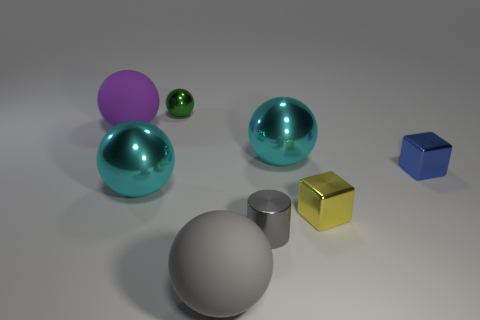Add 1 gray metallic cylinders. How many objects exist? 9 Subtract all cyan metallic balls. How many balls are left? 3 Subtract all spheres. How many objects are left? 3 Subtract 2 balls. How many balls are left? 3 Subtract all green balls. How many balls are left? 4 Subtract all green balls. How many yellow blocks are left? 1 Subtract all small spheres. Subtract all large metallic balls. How many objects are left? 5 Add 3 large cyan spheres. How many large cyan spheres are left? 5 Add 6 big gray things. How many big gray things exist? 7 Subtract 1 yellow cubes. How many objects are left? 7 